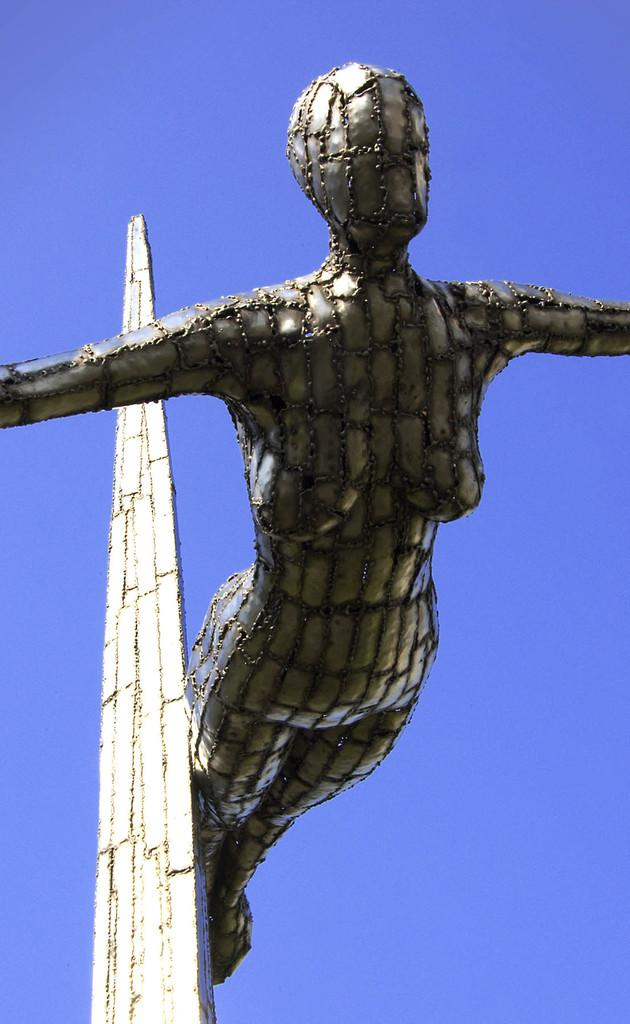What color is the sky in the image? The sky is blue in the image. What is the main object featured in the image? There is a statue in the image. Where is the hydrant located in the image? There is no hydrant present in the image. What message of hope is conveyed by the statue in the image? The image does not convey a specific message of hope, as it only features a statue without any context or additional information. 